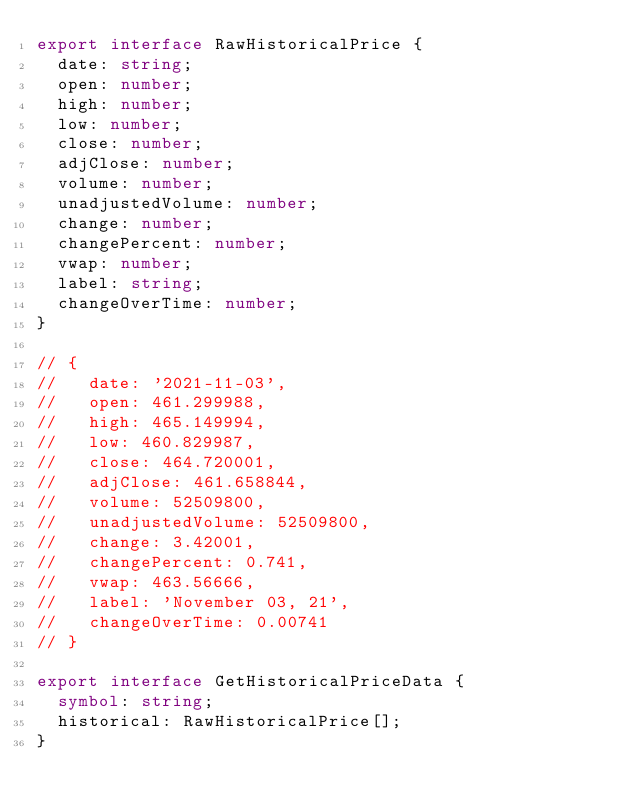<code> <loc_0><loc_0><loc_500><loc_500><_TypeScript_>export interface RawHistoricalPrice {
  date: string;
  open: number;
  high: number;
  low: number;
  close: number;
  adjClose: number;
  volume: number;
  unadjustedVolume: number;
  change: number;
  changePercent: number;
  vwap: number;
  label: string;
  changeOverTime: number;
}

// {
//   date: '2021-11-03',
//   open: 461.299988,
//   high: 465.149994,
//   low: 460.829987,
//   close: 464.720001,
//   adjClose: 461.658844,
//   volume: 52509800,
//   unadjustedVolume: 52509800,
//   change: 3.42001,
//   changePercent: 0.741,
//   vwap: 463.56666,
//   label: 'November 03, 21',
//   changeOverTime: 0.00741
// }

export interface GetHistoricalPriceData {
  symbol: string;
  historical: RawHistoricalPrice[];
}
</code> 